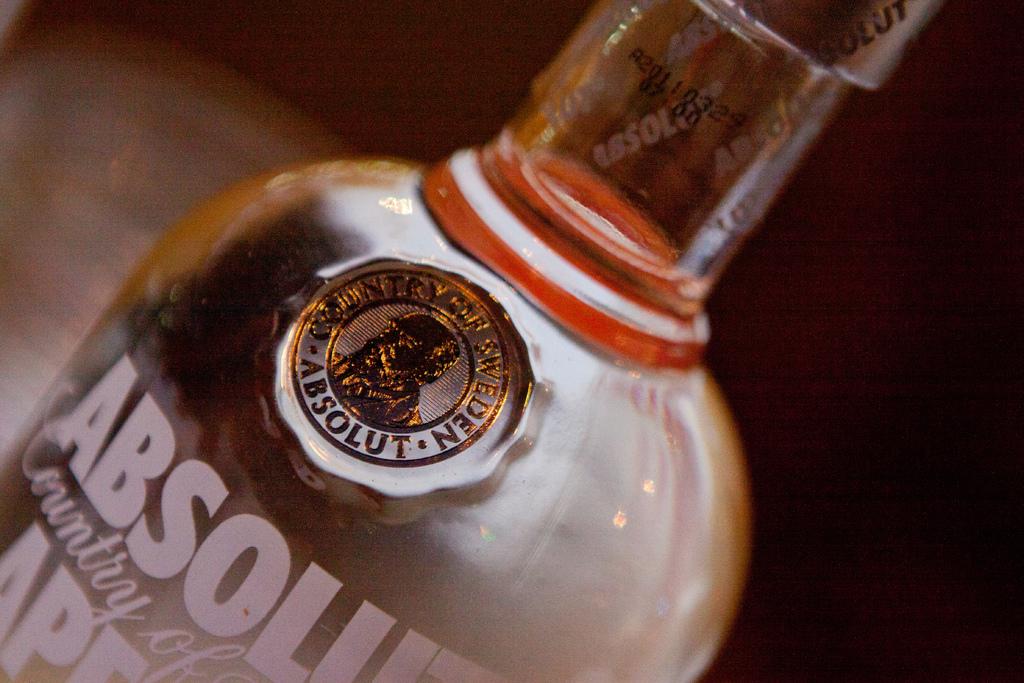What is the brand?
Your response must be concise. Absolut. What country was this made in?
Your answer should be very brief. Sweden. 